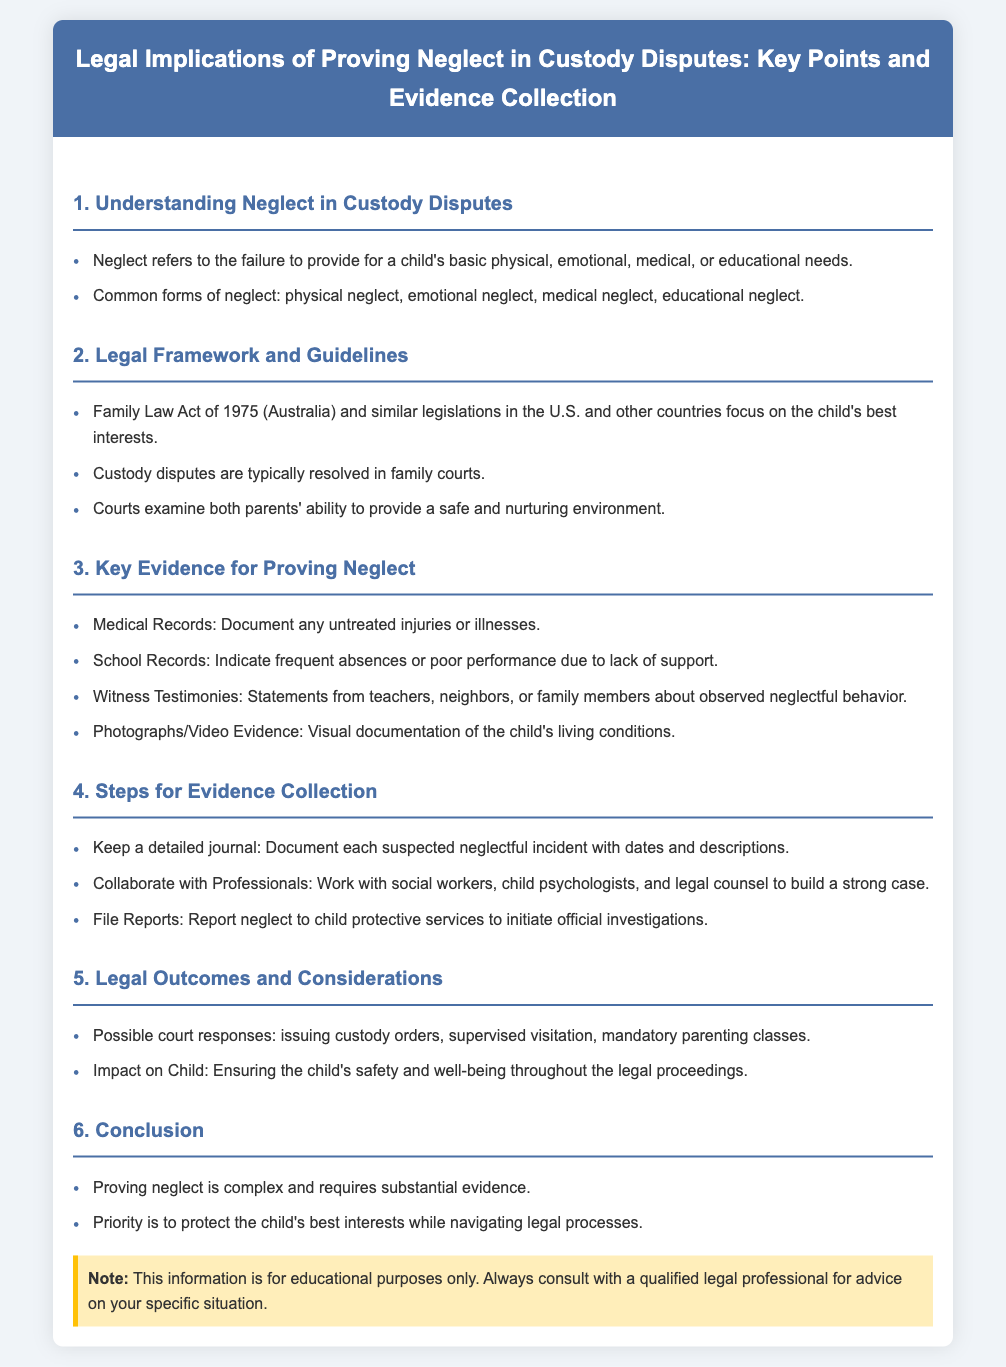What does neglect refer to? Neglect refers to the failure to provide for a child's basic physical, emotional, medical, or educational needs.
Answer: failure to provide for a child's basic needs What is one common form of neglect? The document lists common forms of neglect, such as physical neglect, emotional neglect, medical neglect, and educational neglect.
Answer: physical neglect Which act focuses on the child's best interests? The Family Law Act of 1975 (Australia) and similar legislations focus on the child's best interests.
Answer: Family Law Act of 1975 What type of records can serve as key evidence? Medical Records, School Records, Witness Testimonies, and Photographs/Video Evidence serve as key evidence for proving neglect.
Answer: Medical Records How can one document suspected neglectful incidents? The document suggests keeping a detailed journal to document each suspected neglectful incident.
Answer: detailed journal What should be reported to initiate official investigations? The document mentions that neglect should be reported to child protective services to initiate official investigations.
Answer: neglect What is the priority throughout the legal proceedings? The priority mentioned in the conclusion is to protect the child's best interests while navigating legal processes.
Answer: protect the child's best interests What can be a possible court response to proving neglect? Possible court responses include issuing custody orders, supervised visitation, and mandatory parenting classes.
Answer: issuing custody orders 